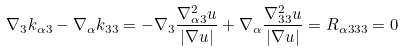<formula> <loc_0><loc_0><loc_500><loc_500>\nabla _ { 3 } k _ { \alpha 3 } - \nabla _ { \alpha } k _ { 3 3 } = - \nabla _ { 3 } \frac { \nabla ^ { 2 } _ { \alpha 3 } u } { | \nabla u | } + \nabla _ { \alpha } \frac { \nabla ^ { 2 } _ { 3 3 } u } { | \nabla u | } = R _ { \alpha 3 3 3 } = 0</formula> 